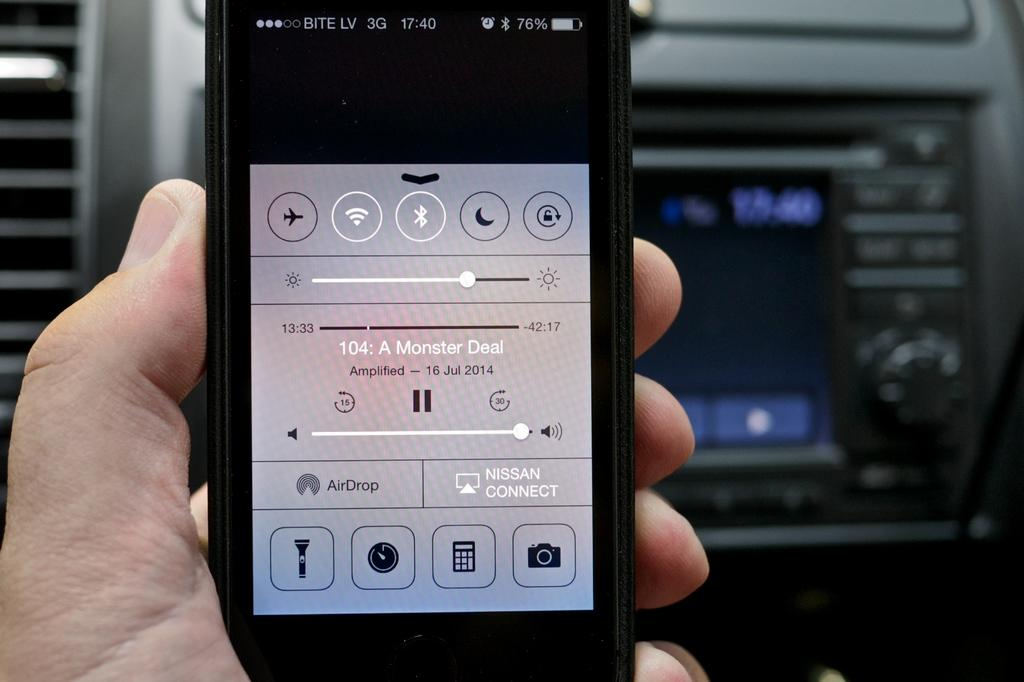<image>
Render a clear and concise summary of the photo. The screen of a cell phone with the song A monster deal shown to be playing in the center. 